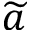Convert formula to latex. <formula><loc_0><loc_0><loc_500><loc_500>\widetilde { a }</formula> 